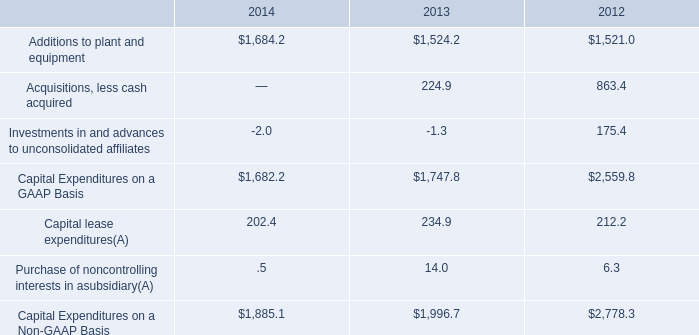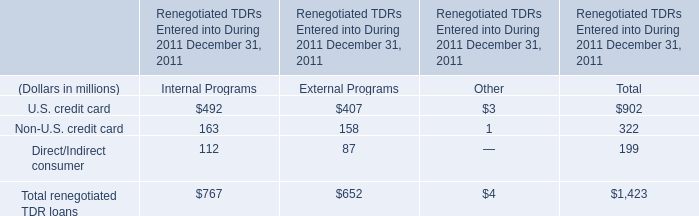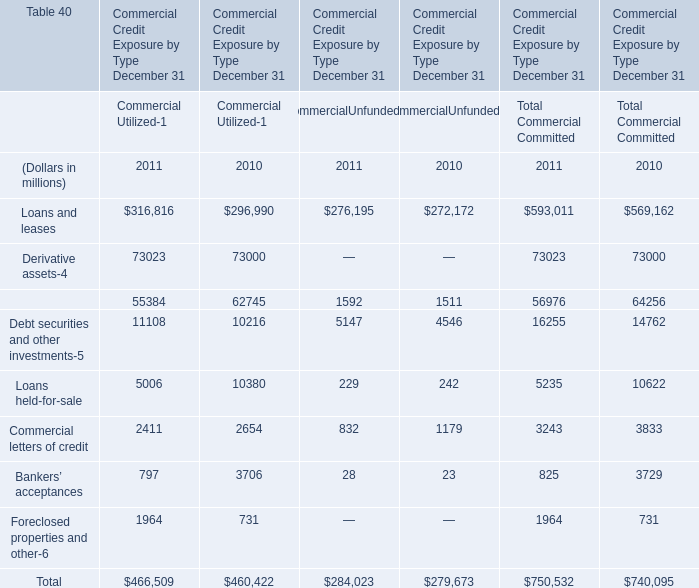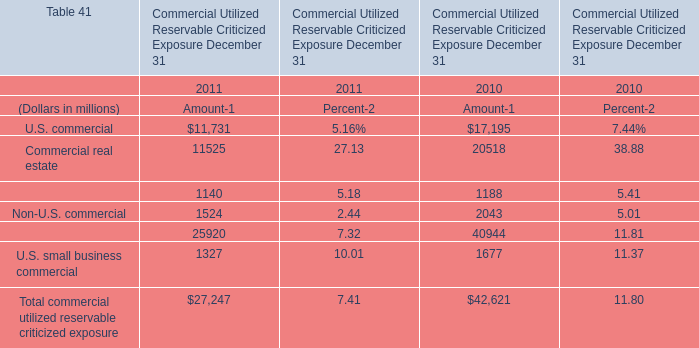What's the total amount of U.S. commercial and Commercial real estate in 2011 for amount? (in million) 
Computations: (11731 + 11525)
Answer: 23256.0. 